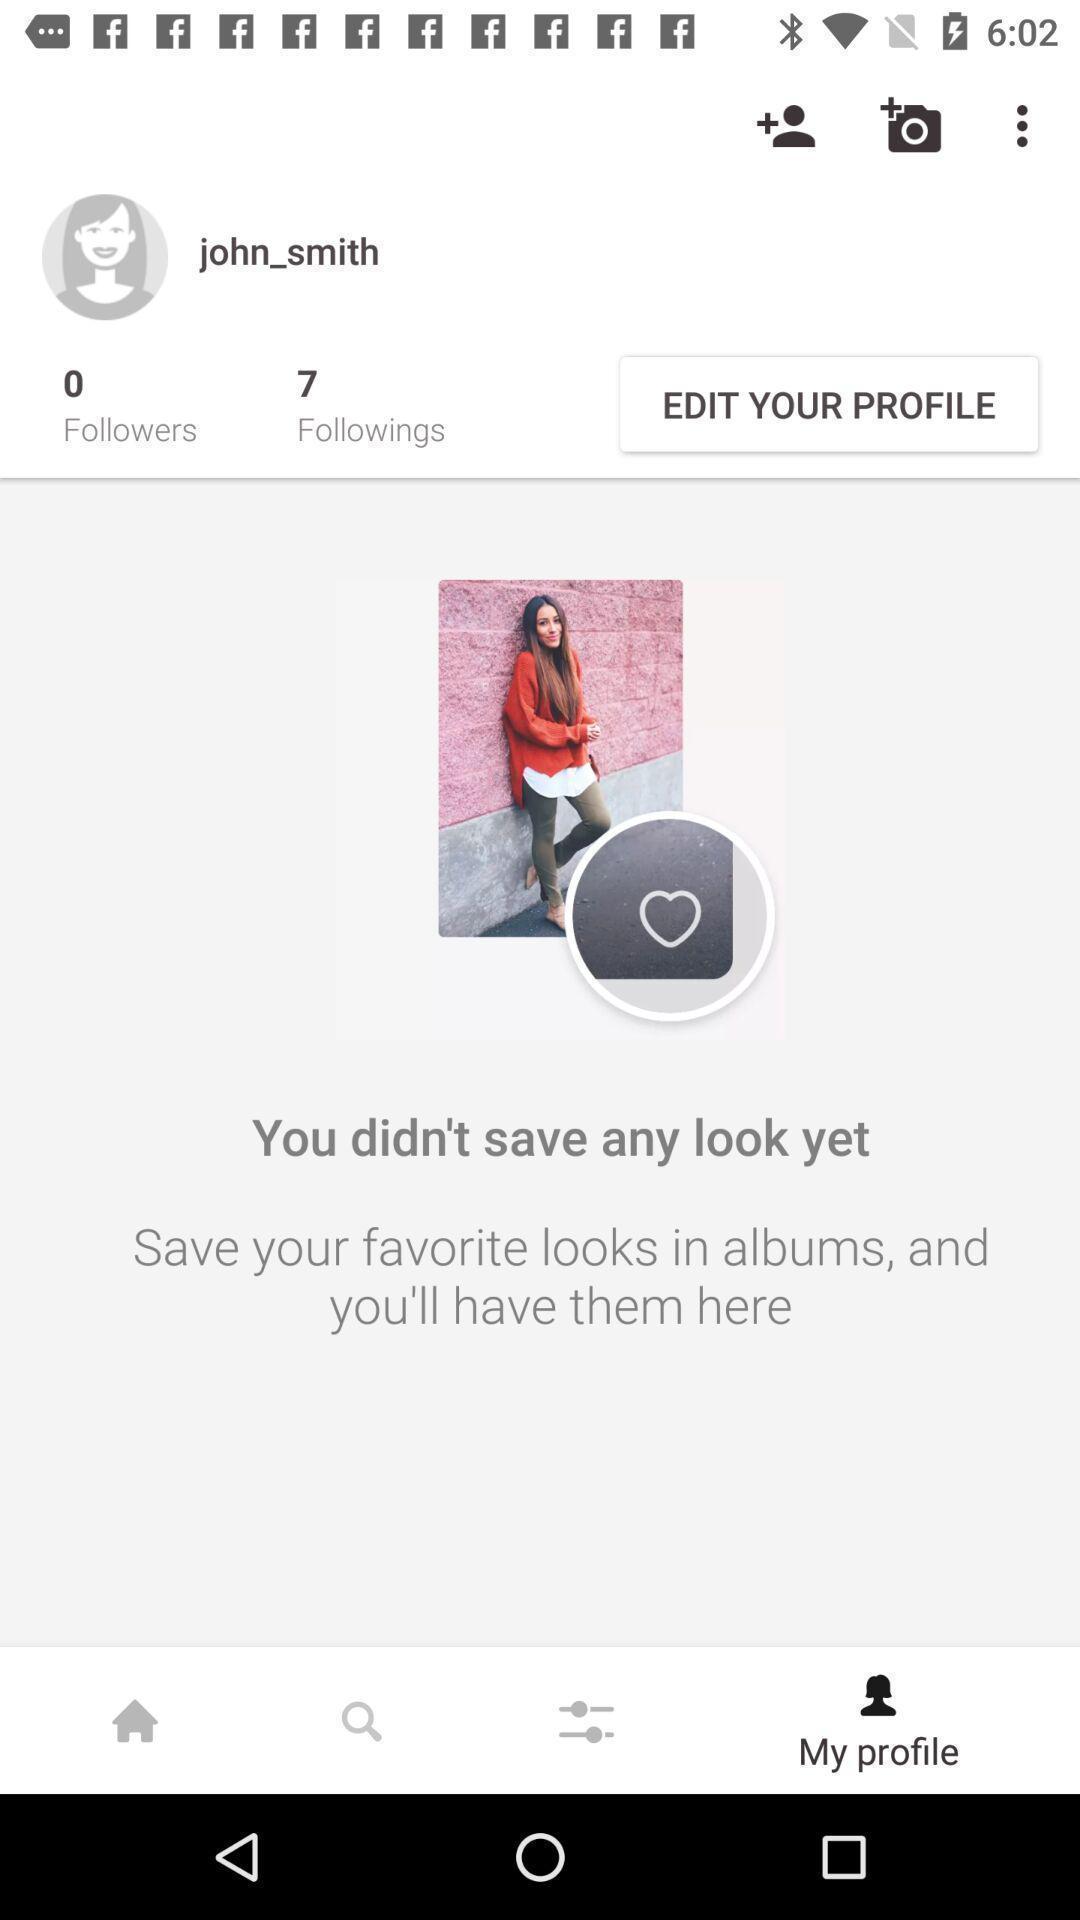Give me a narrative description of this picture. Screen shows the profile of a person with different options. 